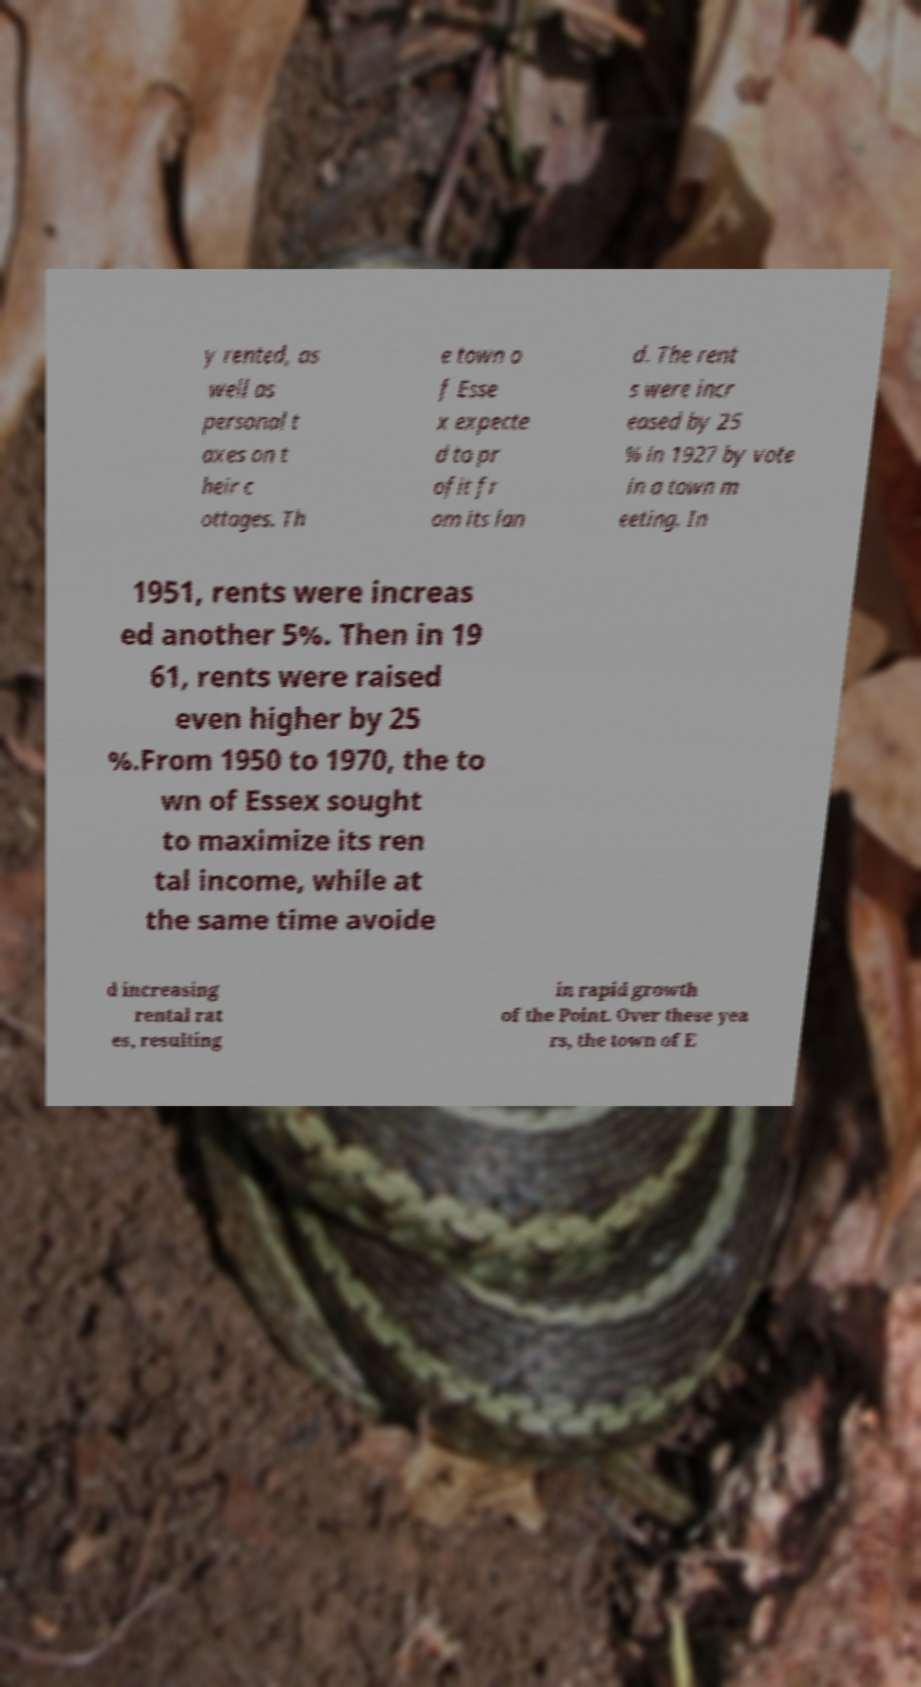For documentation purposes, I need the text within this image transcribed. Could you provide that? y rented, as well as personal t axes on t heir c ottages. Th e town o f Esse x expecte d to pr ofit fr om its lan d. The rent s were incr eased by 25 % in 1927 by vote in a town m eeting. In 1951, rents were increas ed another 5%. Then in 19 61, rents were raised even higher by 25 %.From 1950 to 1970, the to wn of Essex sought to maximize its ren tal income, while at the same time avoide d increasing rental rat es, resulting in rapid growth of the Point. Over these yea rs, the town of E 